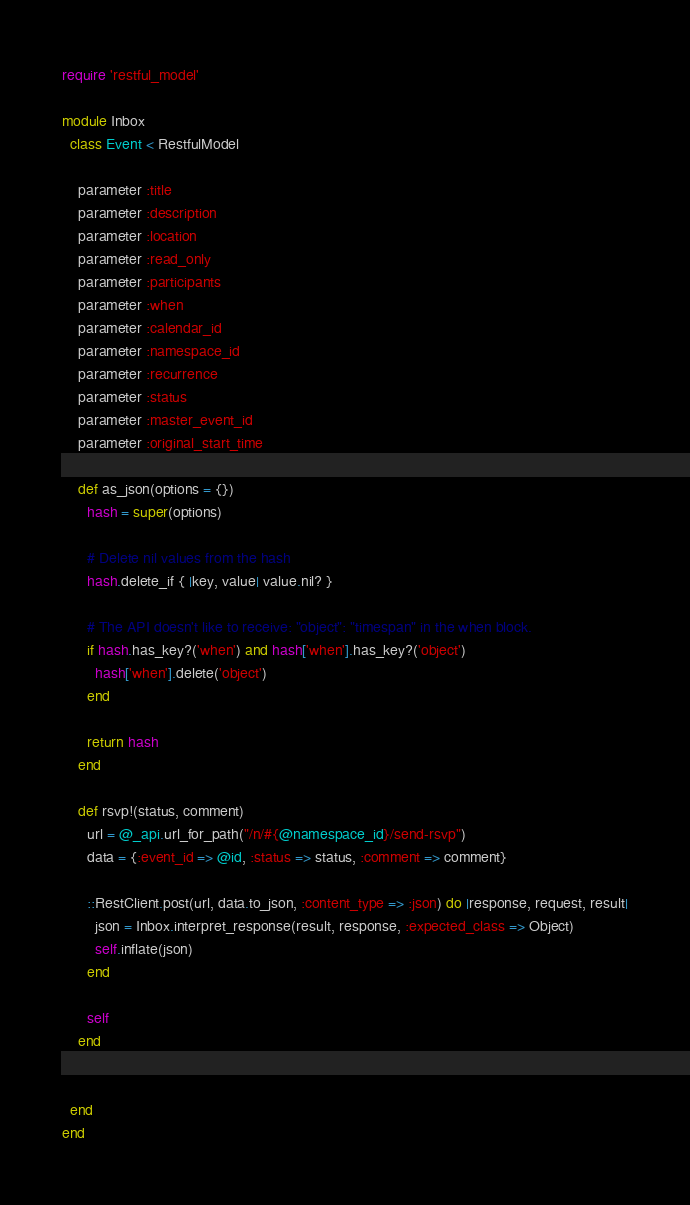<code> <loc_0><loc_0><loc_500><loc_500><_Ruby_>require 'restful_model'

module Inbox
  class Event < RestfulModel

    parameter :title
    parameter :description
    parameter :location
    parameter :read_only
    parameter :participants
    parameter :when
    parameter :calendar_id
    parameter :namespace_id
    parameter :recurrence
    parameter :status
    parameter :master_event_id
    parameter :original_start_time

    def as_json(options = {})
      hash = super(options)

      # Delete nil values from the hash
      hash.delete_if { |key, value| value.nil? }

      # The API doesn't like to receive: "object": "timespan" in the when block.
      if hash.has_key?('when') and hash['when'].has_key?('object')
        hash['when'].delete('object')
      end

      return hash
    end

    def rsvp!(status, comment)
      url = @_api.url_for_path("/n/#{@namespace_id}/send-rsvp")
      data = {:event_id => @id, :status => status, :comment => comment}

      ::RestClient.post(url, data.to_json, :content_type => :json) do |response, request, result|
        json = Inbox.interpret_response(result, response, :expected_class => Object)
        self.inflate(json)
      end

      self
    end


  end
end
</code> 